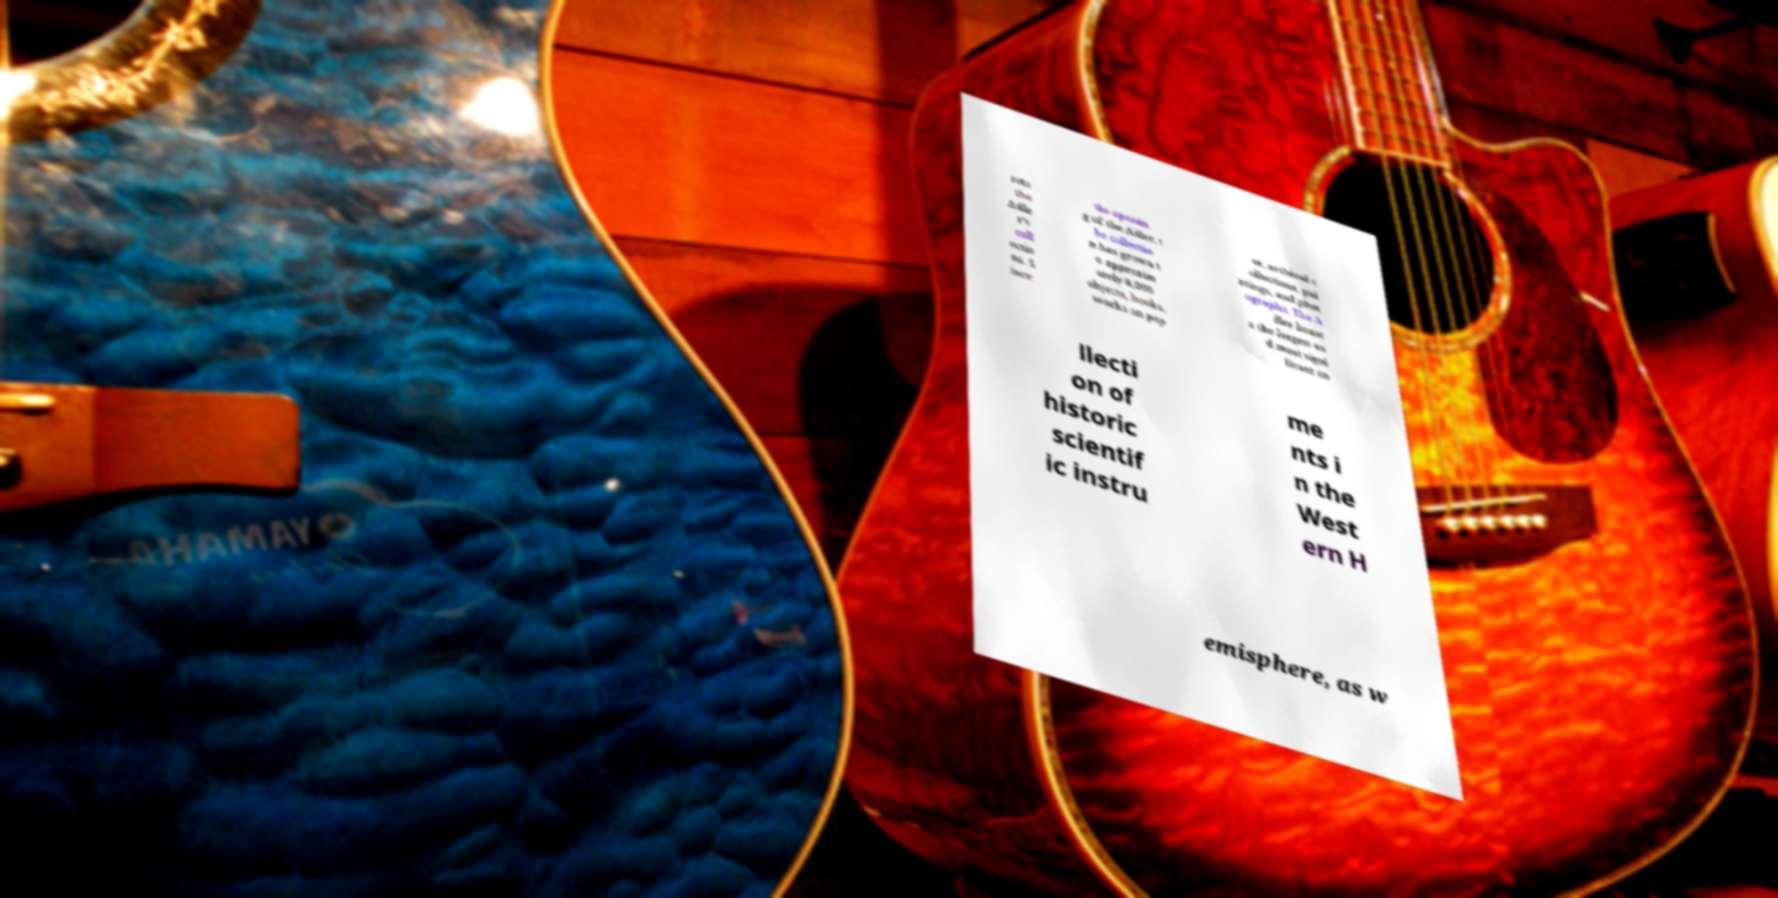Can you accurately transcribe the text from the provided image for me? rets the Adle r's coll ectio ns. S ince the openin g of the Adler, t he collectio n has grown t o approxim ately 8,000 objects, books, works on pap er, archival c ollections, pai ntings, and phot ographs. The A dler boast s the largest an d most signi ficant co llecti on of historic scientif ic instru me nts i n the West ern H emisphere, as w 